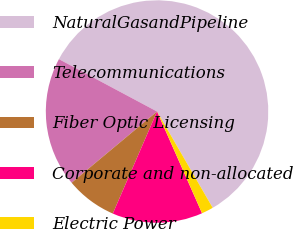Convert chart to OTSL. <chart><loc_0><loc_0><loc_500><loc_500><pie_chart><fcel>NaturalGasandPipeline<fcel>Telecommunications<fcel>Fiber Optic Licensing<fcel>Corporate and non-allocated<fcel>Electric Power<nl><fcel>58.86%<fcel>18.86%<fcel>7.43%<fcel>13.14%<fcel>1.71%<nl></chart> 